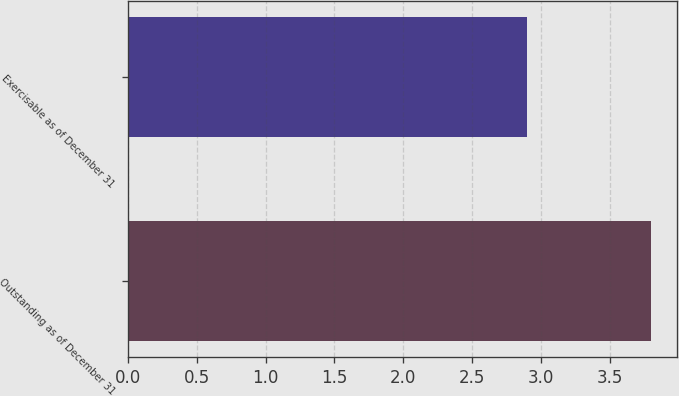Convert chart to OTSL. <chart><loc_0><loc_0><loc_500><loc_500><bar_chart><fcel>Outstanding as of December 31<fcel>Exercisable as of December 31<nl><fcel>3.8<fcel>2.9<nl></chart> 